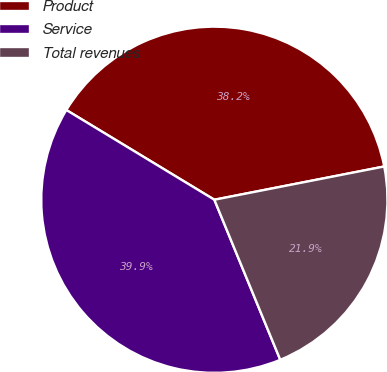Convert chart to OTSL. <chart><loc_0><loc_0><loc_500><loc_500><pie_chart><fcel>Product<fcel>Service<fcel>Total revenues<nl><fcel>38.25%<fcel>39.89%<fcel>21.86%<nl></chart> 